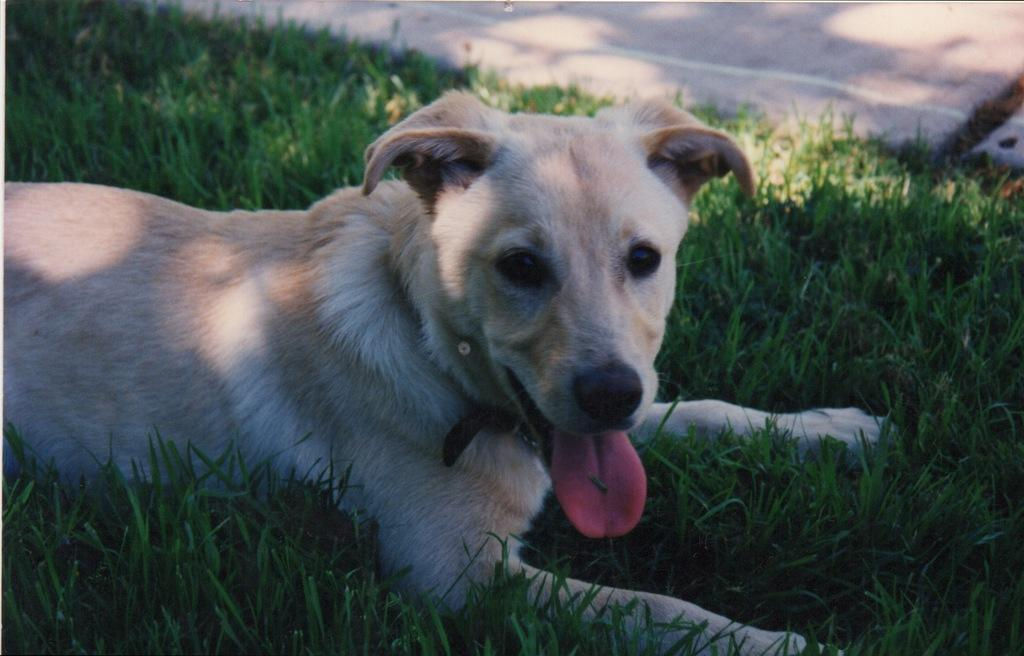What type of animal is present in the image? There is a dog in the image. What type of terrain is visible in the image? There is grass in the image. What type of man-made structure can be seen in the image? There is a road in the image. What type of knee injury does the dog have in the image? There is no indication of a knee injury in the image; the dog appears to be healthy and active. 